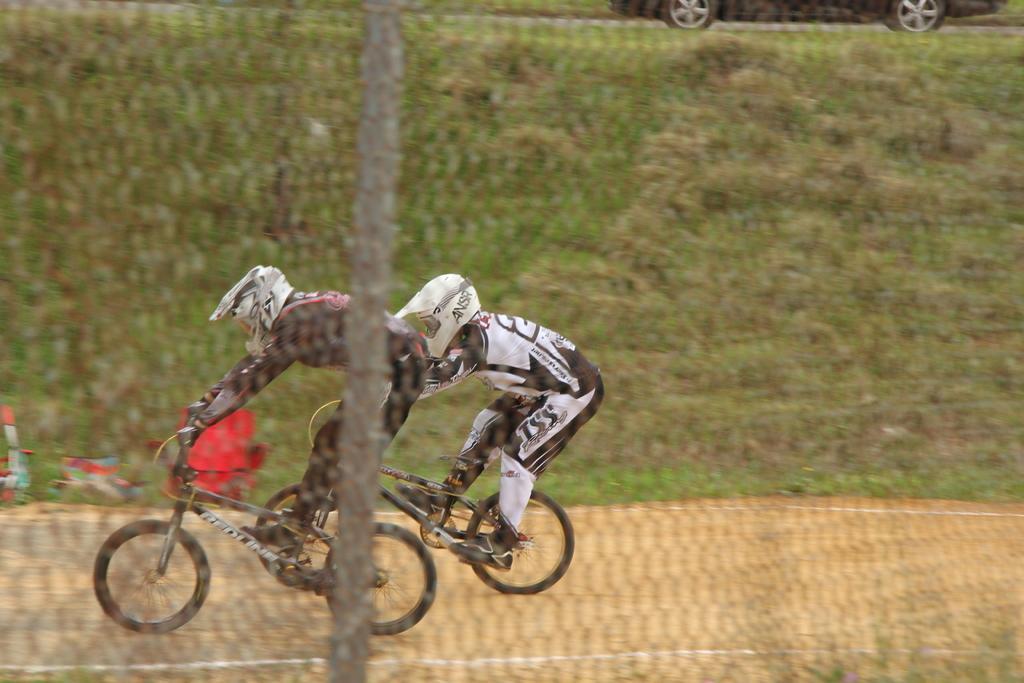Can you describe this image briefly? In this image we can see two persons riding bicycle. In the background of the image there is grass. There is a car. In the foreground of the image there is a net. 